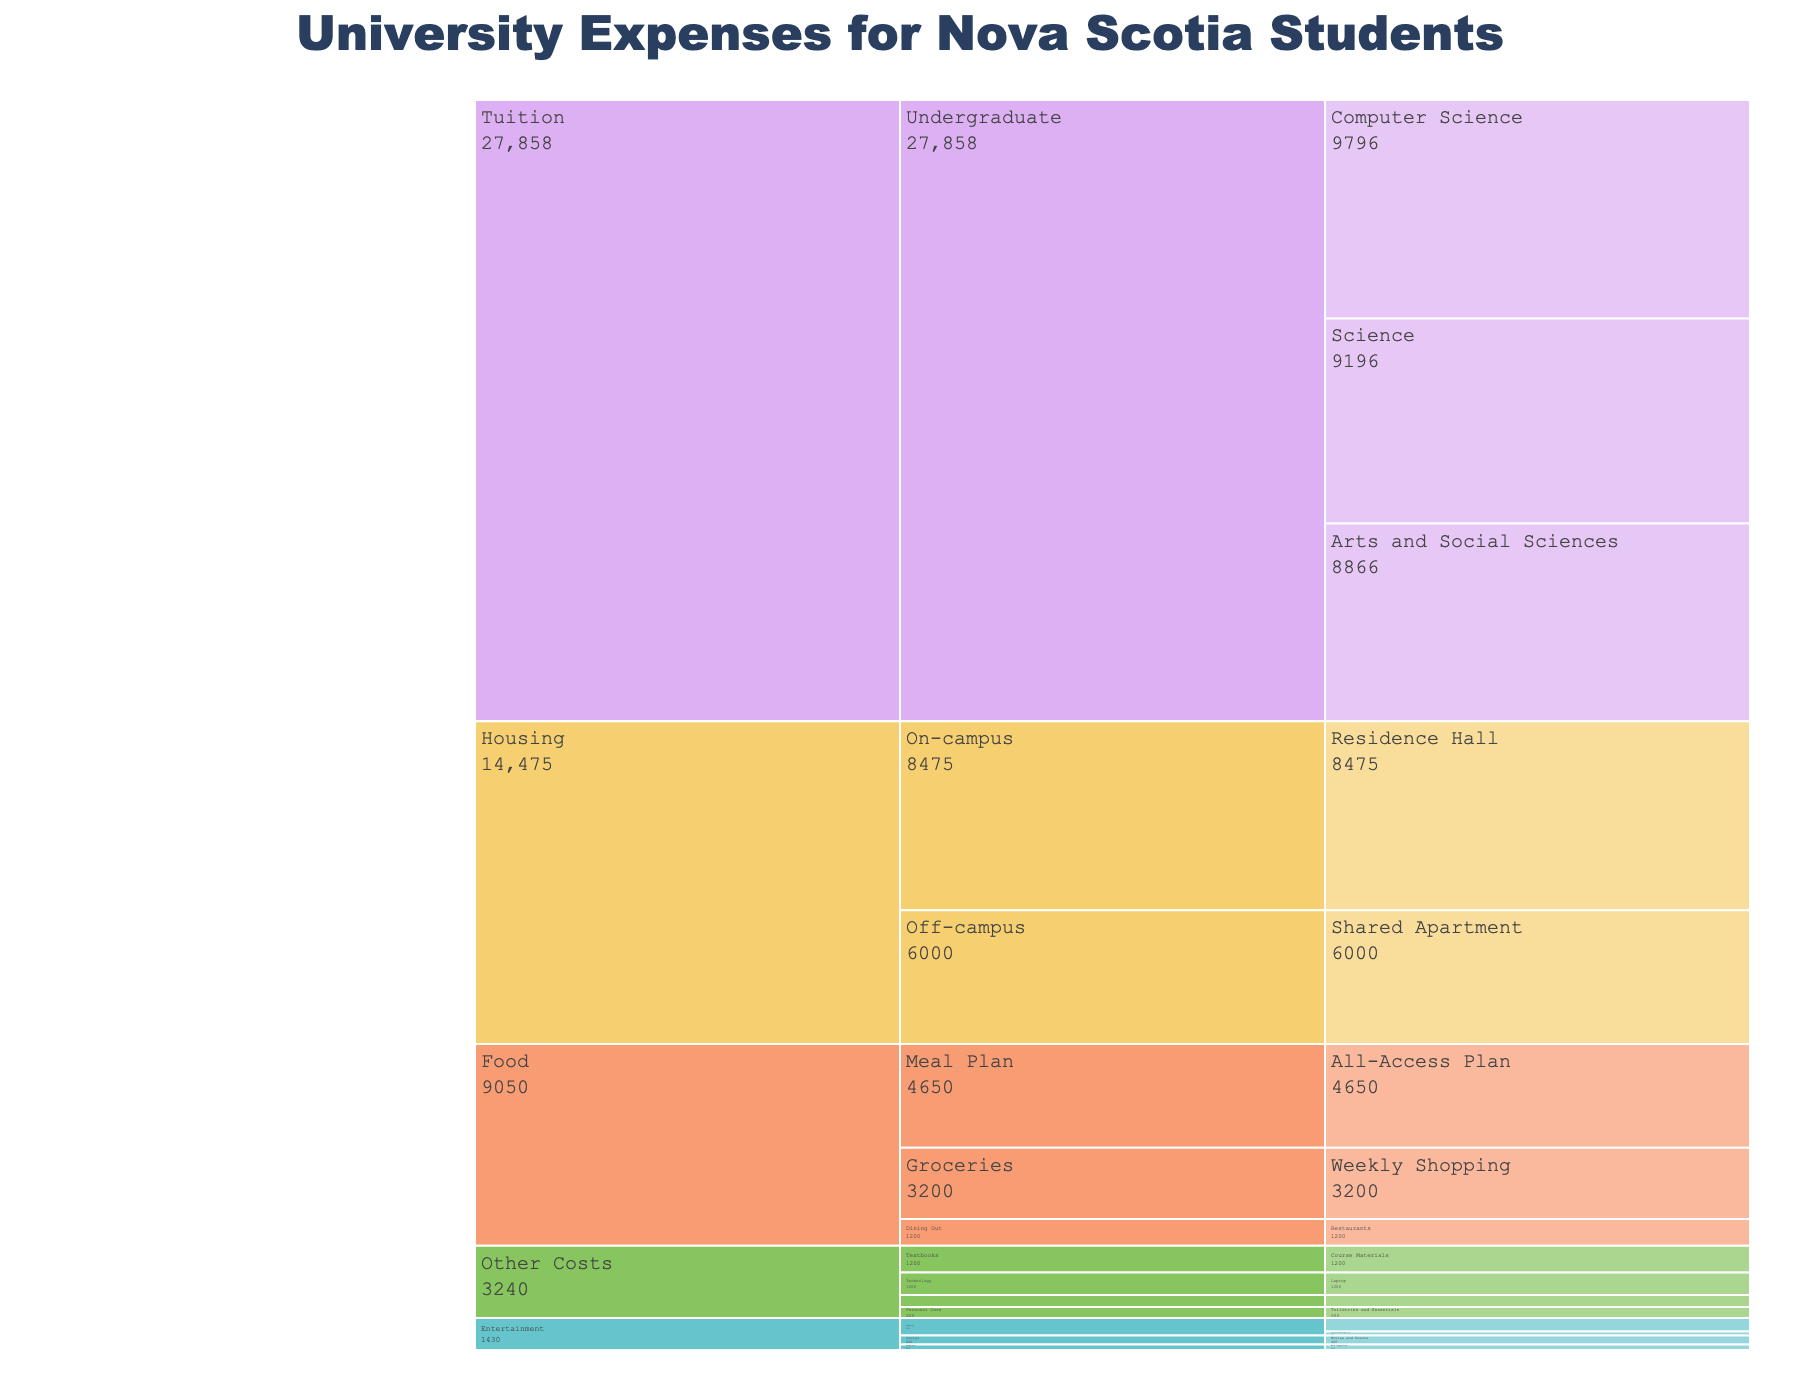What is the total cost of Tuition for Computer Science students? From the icicle chart, locate the 'Tuition' section, find 'Undergraduate' under it, and identify 'Computer Science'. The cost is shown there.
Answer: 9796 Which has a higher expense, Groceries or Dining Out under the Food category? From the Food section, compare the cost values of 'Groceries' and 'Dining Out'. Groceries cost 3200 while Dining Out costs 1200. Groceries are higher.
Answer: Groceries What is the least expensive item under Entertainment? Look at the Entertainment section in the icicle chart, and identify the item with the smallest cost. 'Online Subscriptions' under Gaming costs 180, which is the least.
Answer: Online Subscriptions How much more does an On-campus Residence Hall cost compared to a Shared Apartment under Housing? Check the 'Housing' section, find the costs of 'Residence Hall' and 'Shared Apartment'. Residence Hall is 8475, while Shared Apartment is 6000. Subtract the smaller from the larger. 8475 - 6000 = 2475
Answer: 2475 What is the sum of the costs of Social and Hobbies items under the Entertainment category? Within the 'Entertainment' section, locate and sum the costs of the 'Social' and 'Hobbies' items. 'Movies and Events' under Social cost 400, and 'Art Supplies' under Hobbies cost 250. Sum them up: 400 + 250 = 650
Answer: 650 How much is the Technology cost under Other Costs? Within the 'Other Costs' category, locate the 'Technology' item and read the cost. 'Laptop' under Technology costs 1000.
Answer: 1000 Is the total cost of all Food items greater or less than the cost of On-campus Residence Hall housing? Sum the costs of 'All-Access Plan', 'Groceries', and 'Dining Out'. 4650 + 3200 + 1200 = 9050. Compare with On-campus Residence Hall cost which is 8475. 9050 is greater.
Answer: Greater What is the difference in cost between 'Weekly Shopping' under Groceries and 'Course Materials' under Textbooks? Find 'Weekly Shopping' in Groceries under Food (3200) and 'Course Materials' under Textbooks in Other Costs (1200). Subtract the smaller from the larger. 3200 - 1200 = 2000
Answer: 2000 What is the median cost value of the subcategories under Tuition? The three subcategory costs under Tuition are: Arts and Social Sciences (8866), Science (9196), and Computer Science (9796). The median is the middle value when sorted. Ordered: 8866, 9196, 9796. The middle value is 9196.
Answer: 9196 